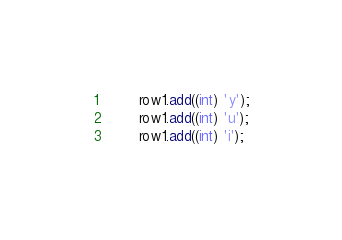<code> <loc_0><loc_0><loc_500><loc_500><_Java_>        row1.add((int) 'y');
        row1.add((int) 'u');
        row1.add((int) 'i');</code> 